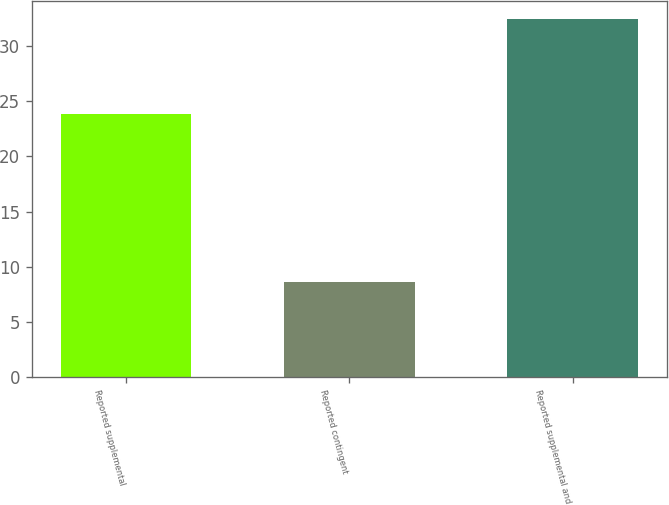<chart> <loc_0><loc_0><loc_500><loc_500><bar_chart><fcel>Reported supplemental<fcel>Reported contingent<fcel>Reported supplemental and<nl><fcel>23.9<fcel>8.6<fcel>32.5<nl></chart> 